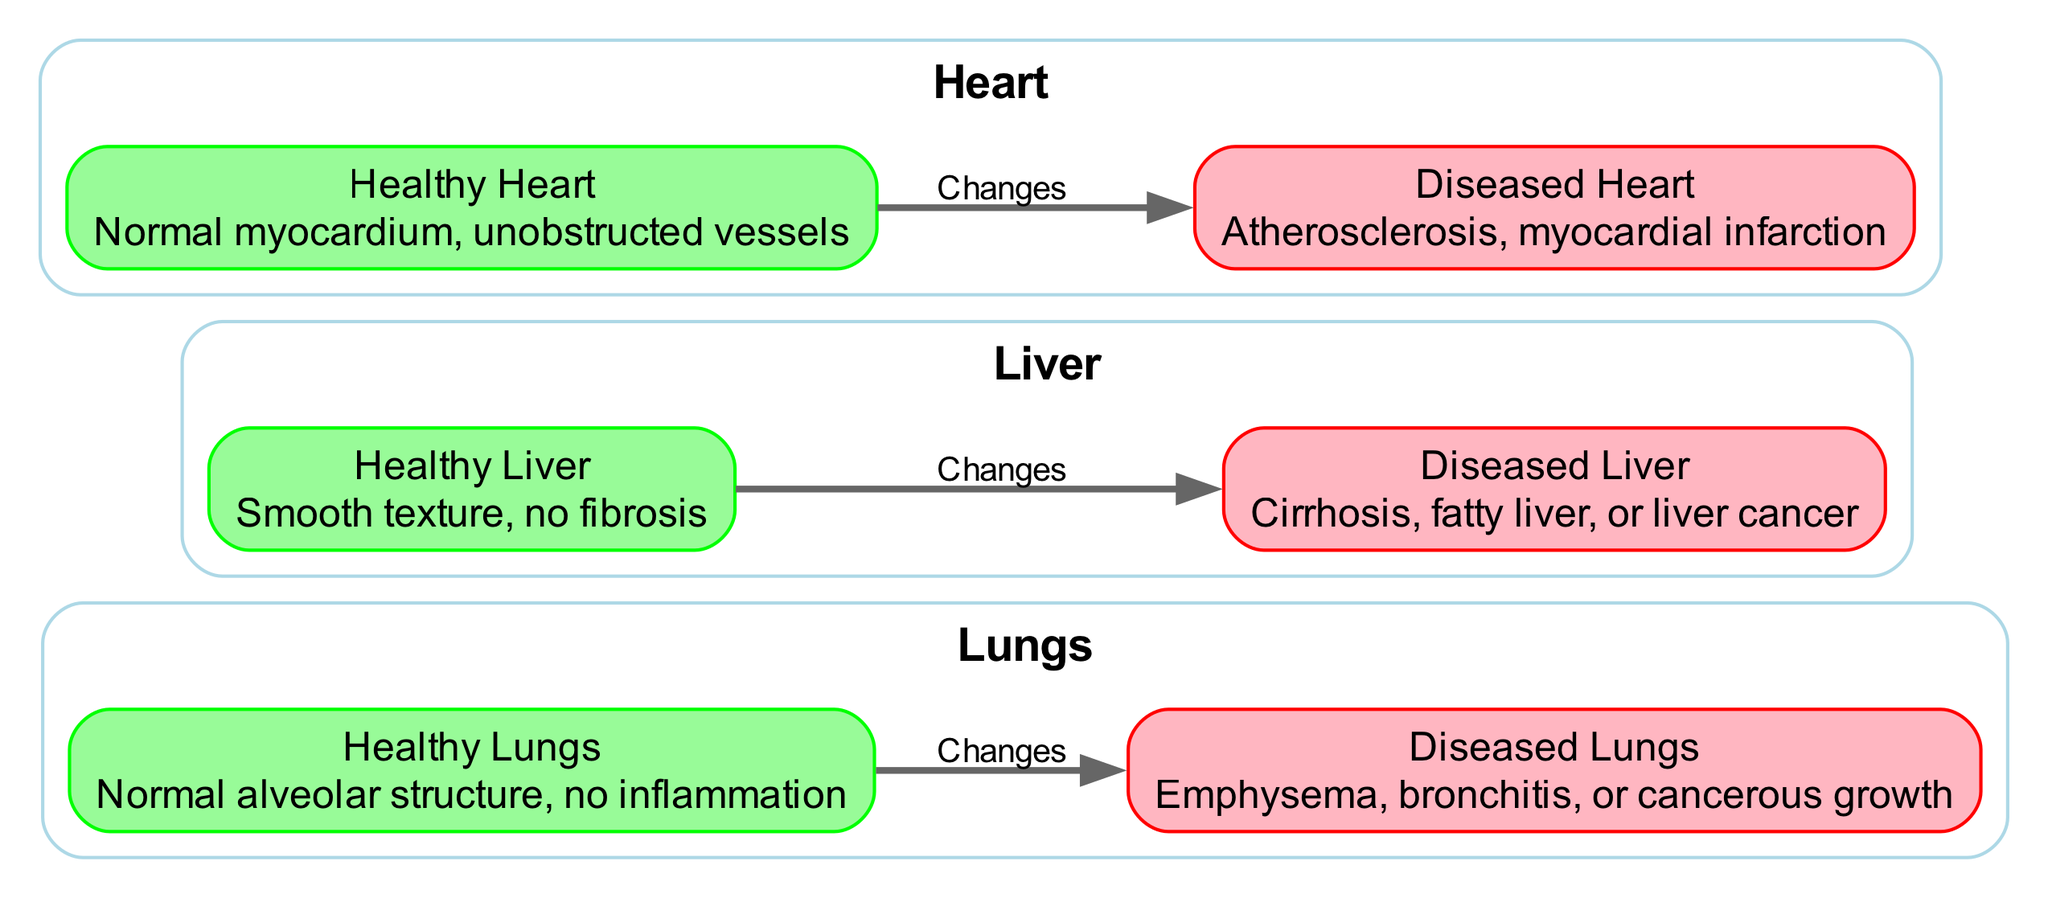What is the label of the healthy lungs? The diagram lists the "Healthy Lungs" node with the label "Healthy Lungs," indicating its identification in the context of the comparison.
Answer: Healthy Lungs How many nodes are present in the diagram? The diagram includes a total of six nodes: Healthy Lungs, Diseased Lungs, Healthy Liver, Diseased Liver, Healthy Heart, and Diseased Heart. Counting these gives us six nodes.
Answer: 6 What condition is associated with the diseased heart? The diagram specifies that the diseased heart can have conditions such as "Atherosclerosis" or "myocardial infarction," this is explicitly mentioned in the description of the diseased heart node.
Answer: Atherosclerosis, myocardial infarction Which organ is associated with cirrhosis? The diagram identifies cirrhosis as a condition related to the "Diseased Liver," directly linking the term to the liver organ in the comparative anatomy context.
Answer: Liver What type of relationship is shown between healthy and diseased organs? The edges in the diagram denote a directional relationship between each healthy organ and its diseased counterpart, indicating a transformation or change, represented as "Changes" in the edge labels.
Answer: Changes What color represents healthy organs in the diagram? The nodes representing healthy organs—specifically Healthy Lungs, Healthy Liver, and Healthy Heart—are filled with "pale green," making it easy to identify healthy organs distinctly.
Answer: Pale green What is the description of the diseased lungs? The "Diseased Lungs" node includes the description "Emphysema, bronchitis, or cancerous growth," clearly stating the conditions that are represented in this part of the diagram.
Answer: Emphysema, bronchitis, or cancerous growth What is the main focus of this biomedical diagram? The title and the content of the diagram clearly indicate that the main focus is on "Comparative Anatomy: Healthy vs. Diseased Organs," emphasizing the differences in structure and conditions of various organs.
Answer: Comparative Anatomy: Healthy vs. Diseased Organs 